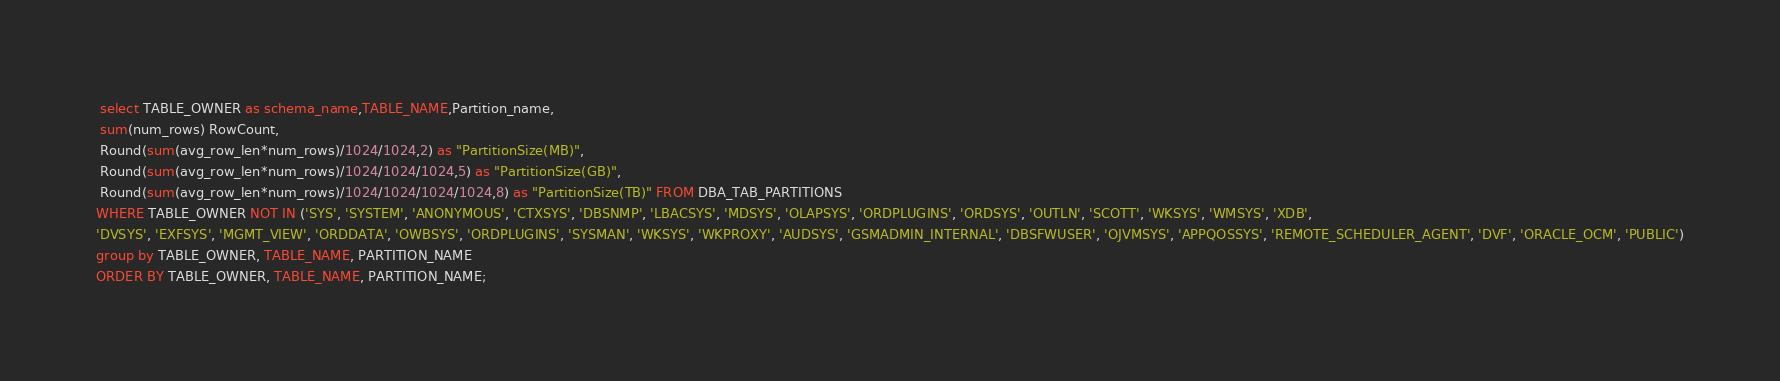Convert code to text. <code><loc_0><loc_0><loc_500><loc_500><_SQL_> select TABLE_OWNER as schema_name,TABLE_NAME,Partition_name,
 sum(num_rows) RowCount,
 Round(sum(avg_row_len*num_rows)/1024/1024,2) as "PartitionSize(MB)",
 Round(sum(avg_row_len*num_rows)/1024/1024/1024,5) as "PartitionSize(GB)",
 Round(sum(avg_row_len*num_rows)/1024/1024/1024/1024,8) as "PartitionSize(TB)" FROM DBA_TAB_PARTITIONS
WHERE TABLE_OWNER NOT IN ('SYS', 'SYSTEM', 'ANONYMOUS', 'CTXSYS', 'DBSNMP', 'LBACSYS', 'MDSYS', 'OLAPSYS', 'ORDPLUGINS', 'ORDSYS', 'OUTLN', 'SCOTT', 'WKSYS', 'WMSYS', 'XDB', 
'DVSYS', 'EXFSYS', 'MGMT_VIEW', 'ORDDATA', 'OWBSYS', 'ORDPLUGINS', 'SYSMAN', 'WKSYS', 'WKPROXY', 'AUDSYS', 'GSMADMIN_INTERNAL', 'DBSFWUSER', 'OJVMSYS', 'APPQOSSYS', 'REMOTE_SCHEDULER_AGENT', 'DVF', 'ORACLE_OCM', 'PUBLIC')
group by TABLE_OWNER, TABLE_NAME, PARTITION_NAME
ORDER BY TABLE_OWNER, TABLE_NAME, PARTITION_NAME;</code> 